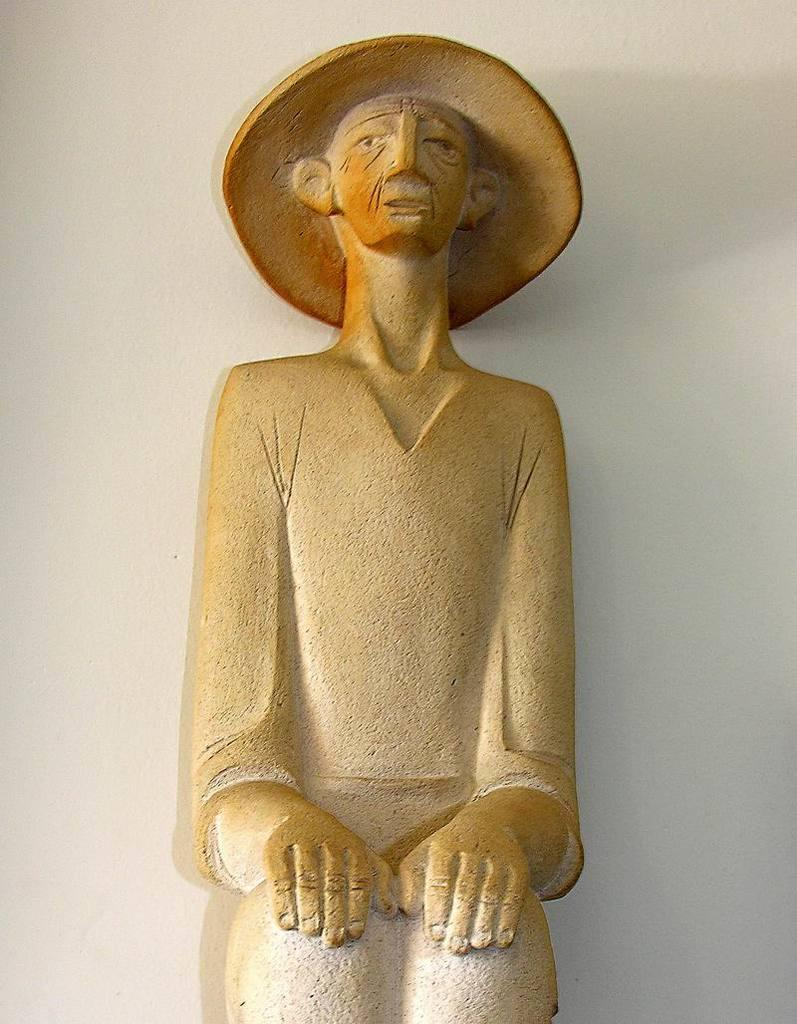What is the main subject of the image? There is a depiction of a person in the center of the image. What can be seen in the background of the image? There is a wall in the background of the image. How many oranges are being held by the person in the image? There are no oranges present in the image. What month is depicted in the image? The image does not depict a specific month or time of year. 